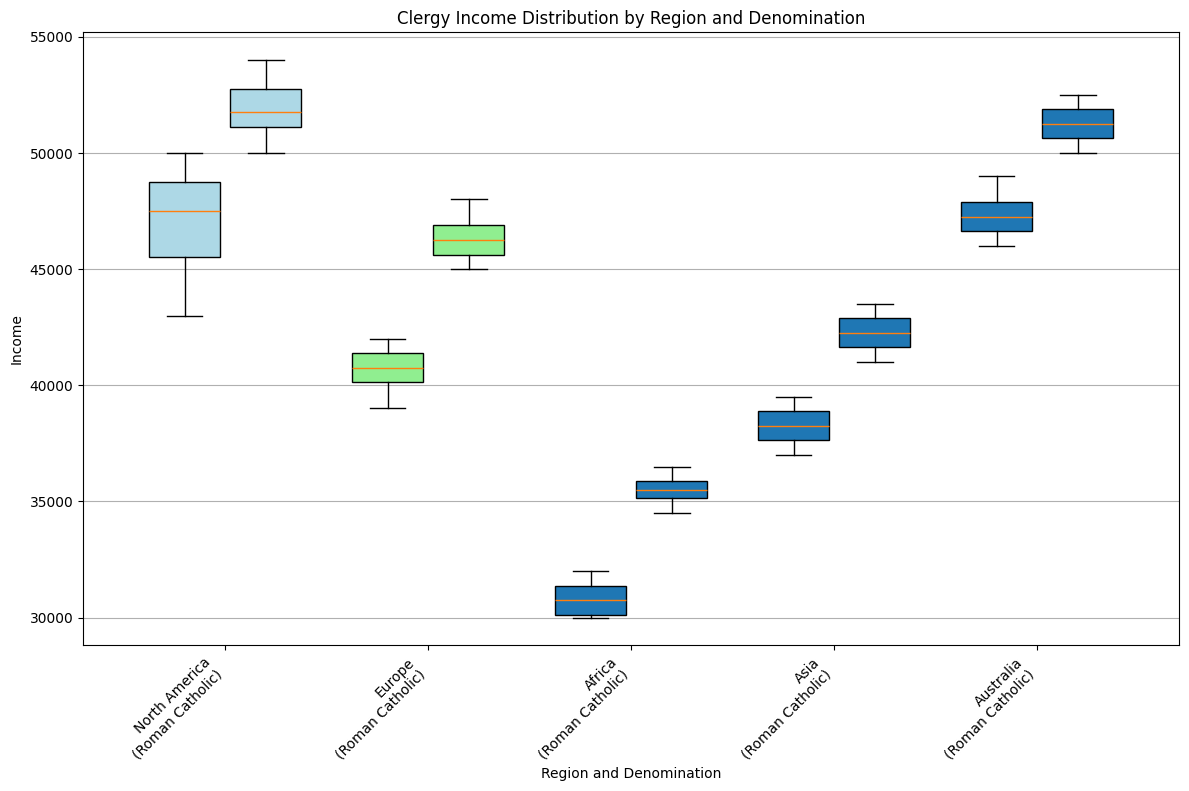What's the median income for Anglican clergy in North America? To find the median income for Anglican clergy in North America, we look at the middle value when the incomes are arranged in ascending order: 43000, 45000, 47000, 48000, 49000, 50000. The middle values are 47000 and 48000. The median is the average of these two figures: (47000 + 48000) / 2 = 47500.
Answer: 47500 Which denomination has a higher median income in Europe, Anglican or Roman Catholic? To determine which denomination has a higher median income in Europe, we compare the medians. For Anglican clergy, the sorted incomes are: 39000, 40000, 40500, 41000, 41500, 42000, with a median of (40500 + 41000) / 2 = 40750. For Roman Catholic clergy, the sorted incomes are: 45000, 45500, 46000, 46500, 47000, 48000, with a median of (46000 + 46500) / 2 = 46250.
Answer: Roman Catholic What is the income range for Roman Catholic clergy in Africa? The income range is found by subtracting the minimum income from the maximum income. The incomes for Roman Catholic clergy in Africa are: 34500, 35000, 35500, 35500, 36000, 36500. The range is 36500 - 34500 = 2000.
Answer: 2000 In which region do Roman Catholic clergy have the highest maximum income? We need to identify the highest maximum income across all regions for Roman Catholic clergy. The maximum incomes are: North America (54000), Europe (48000), Africa (36500), Asia (43500), and Australia (52500). The highest is in North America (54000).
Answer: North America How does the interquartile range (IQR) of Anglican clergy in Asia compare to Europe? The IQR is the difference between the 75th percentile and the 25th percentile. In Asia for Anglican clergy, sorted incomes: 37000, 37500, 38000, 38500, 39000, 39500. Q1 is 37500, Q3 is 39000, IQR = 39000 - 37500 = 1500. In Europe: 39000, 40000, 40500, 41000, 41500, 42000. Q1 is 40000, Q3 is 41500, IQR = 41500 - 40000 = 1500.
Answer: They are equal Which region shows the most variability in Anglican clergy income? Variability is typically measured by the range or standard deviation. For simplicity, examine the ranges: North America (49000 - 43000 = 6000), Europe (42000 - 39000 = 3000), Africa (32000 - 30000 = 2000), Asia (39500 - 37000 = 2500), and Australia (49000 - 46000 = 3000). The highest range is in North America (6000).
Answer: North America 